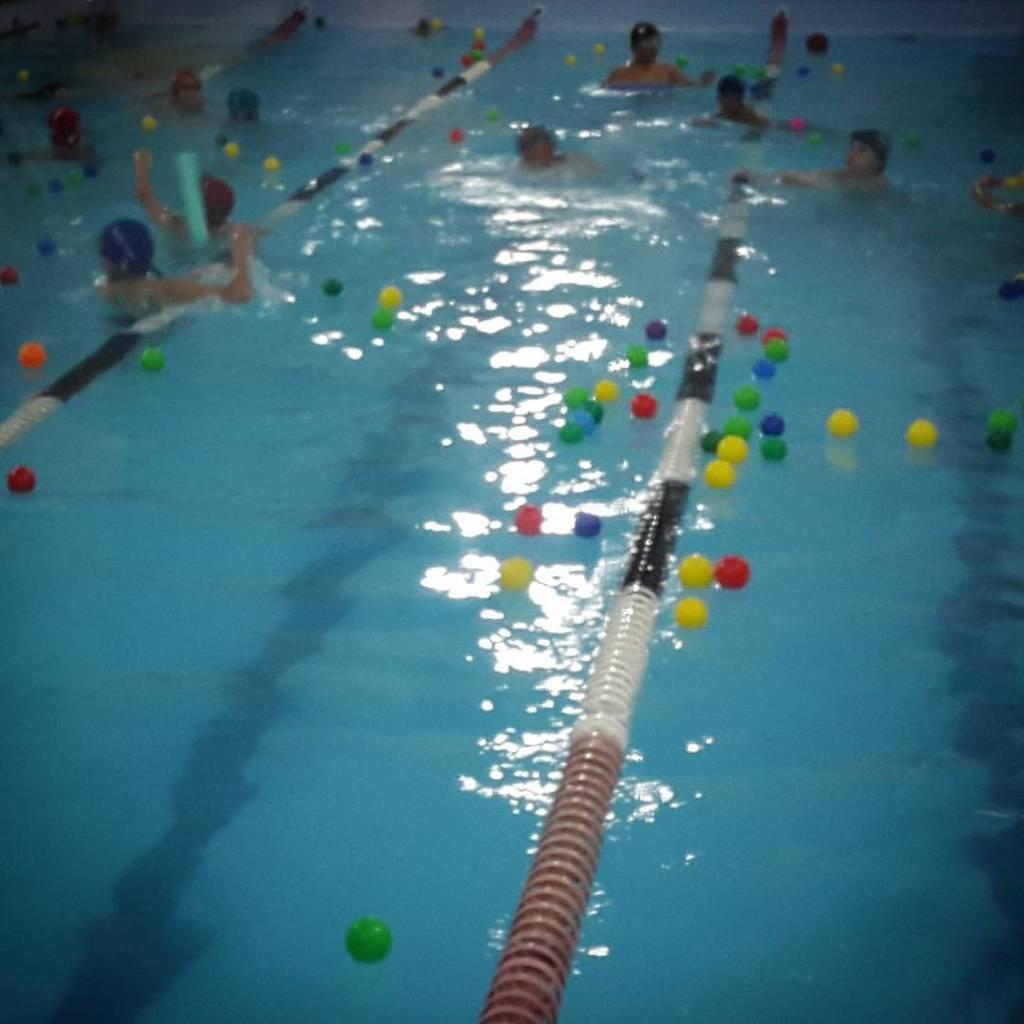Please provide a concise description of this image. This is a picture of a swimming pool were so many people are swimming and on the surface of water some balls are present. 